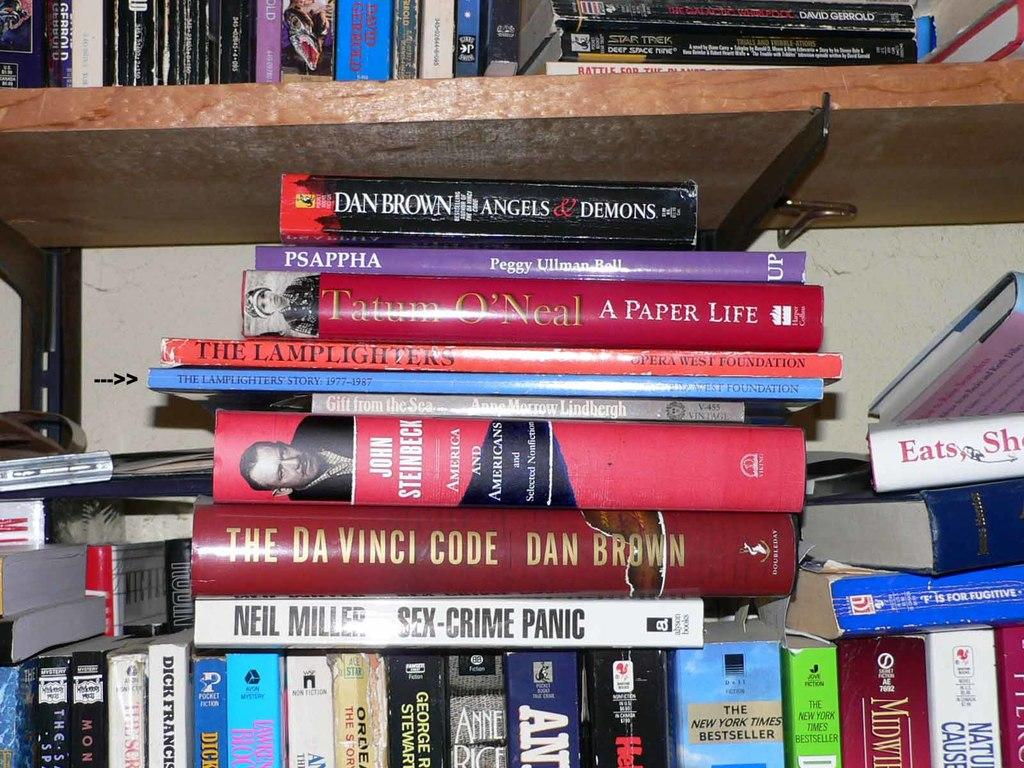What is the main subject of the image? The main subject of the image is a bunch of books. Where are the books located in the image? The books are in shelves. What type of government is depicted in the image? There is no depiction of a government in the image; it features a bunch of books in shelves. How many oranges are visible in the image? There are no oranges present in the image. 